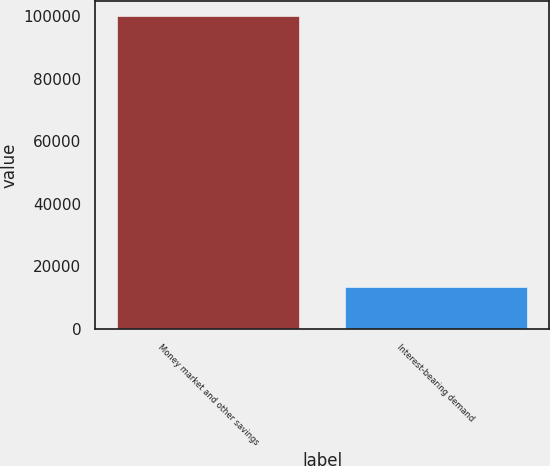Convert chart to OTSL. <chart><loc_0><loc_0><loc_500><loc_500><bar_chart><fcel>Money market and other savings<fcel>Interest-bearing demand<nl><fcel>99881<fcel>13583<nl></chart> 